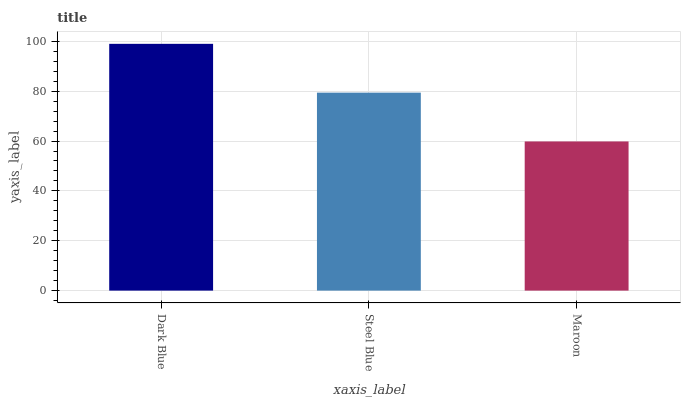Is Maroon the minimum?
Answer yes or no. Yes. Is Dark Blue the maximum?
Answer yes or no. Yes. Is Steel Blue the minimum?
Answer yes or no. No. Is Steel Blue the maximum?
Answer yes or no. No. Is Dark Blue greater than Steel Blue?
Answer yes or no. Yes. Is Steel Blue less than Dark Blue?
Answer yes or no. Yes. Is Steel Blue greater than Dark Blue?
Answer yes or no. No. Is Dark Blue less than Steel Blue?
Answer yes or no. No. Is Steel Blue the high median?
Answer yes or no. Yes. Is Steel Blue the low median?
Answer yes or no. Yes. Is Dark Blue the high median?
Answer yes or no. No. Is Maroon the low median?
Answer yes or no. No. 